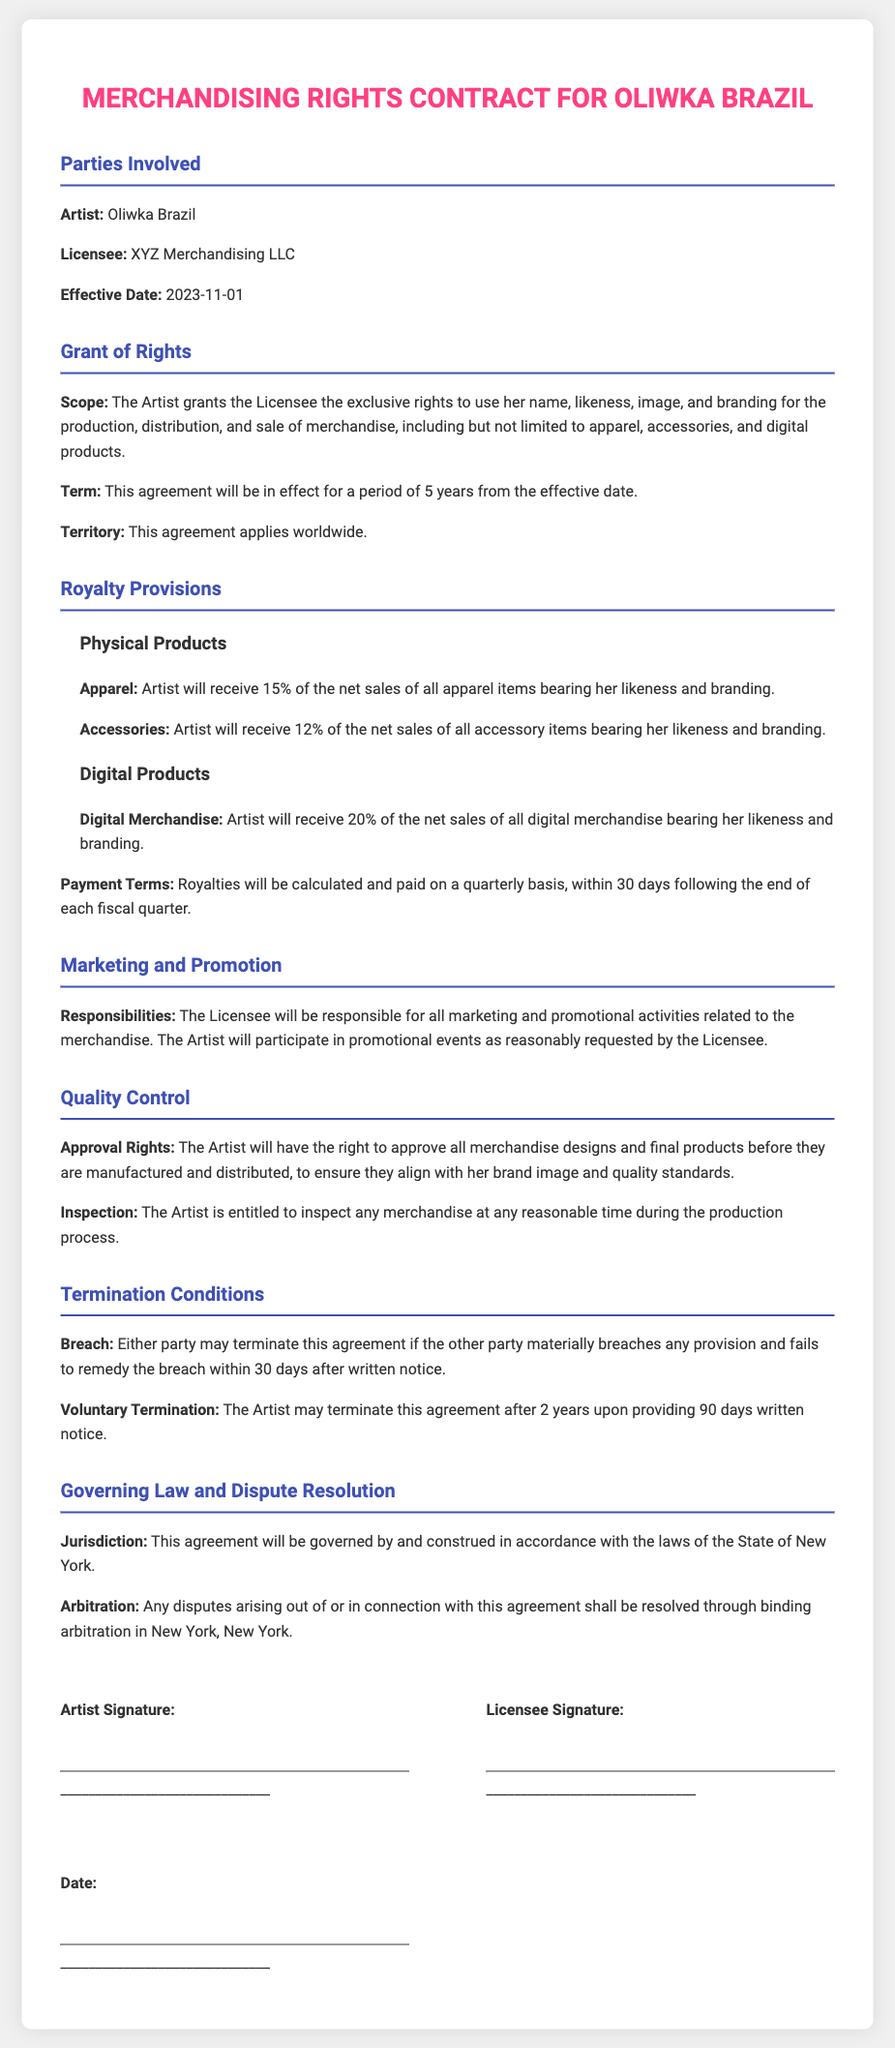What is the artist's name? The artist mentioned in the contract is referred to as Oliwka Brazil.
Answer: Oliwka Brazil What is the effective date of the contract? The effective date of the contract is explicitly stated in the document.
Answer: 2023-11-01 What percentage royalty does the artist receive from apparel sales? The contract specifies a 15% royalty for the artist's apparel sales.
Answer: 15% What is the term duration of the agreement? The duration of the agreement is indicated in the Grant of Rights section.
Answer: 5 years What territory does the contract cover? The document specifies that the agreement applies worldwide.
Answer: Worldwide What are the artist's approval rights regarding merchandise? The document mentions that the artist has the right to approve all merchandise designs before manufacturing.
Answer: Approval Rights Under what circumstances can either party terminate the agreement? The document details that material breach without remedy within 30 days constitutes grounds for termination.
Answer: Material breach What is the governing law for the contract? The jurisdiction for the contract is specified in the Governing Law section.
Answer: State of New York What will be the payment terms for royalties? Payment for royalties will be calculated and paid on a quarterly basis according to the document.
Answer: Quarterly basis 